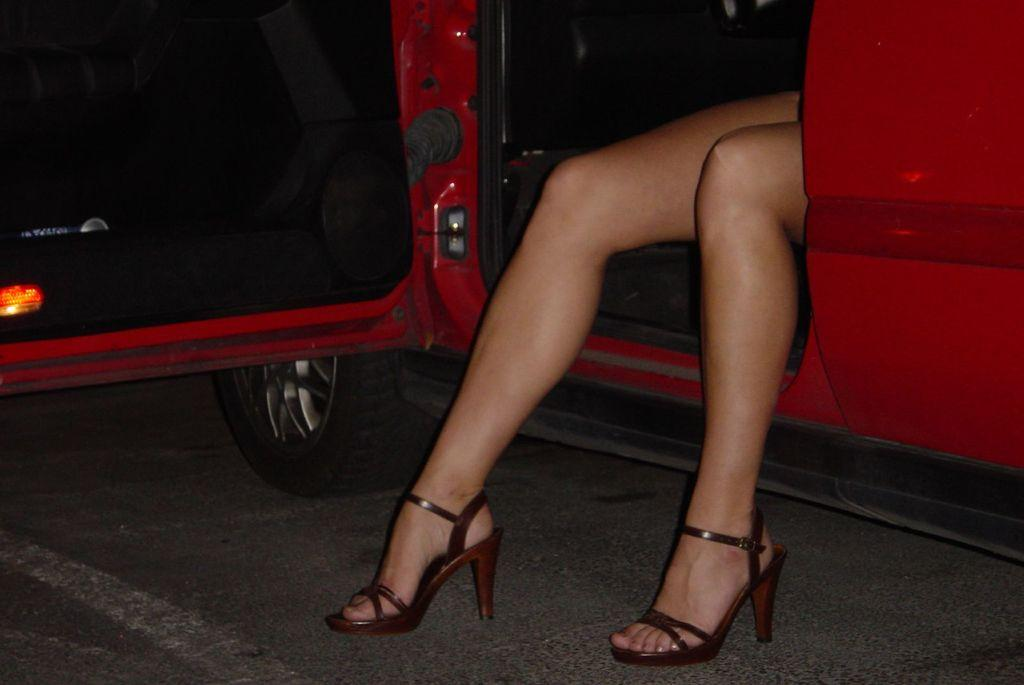What color is the vehicle in the image? The vehicle in the image is red. Where is the vehicle located? The vehicle is on a road. Who is inside the vehicle? There is a person sitting in the vehicle. What type of footwear is the person wearing? The person is wearing heels. What statement is the person making while sitting in the vehicle? There is no information about any statements being made in the image. 